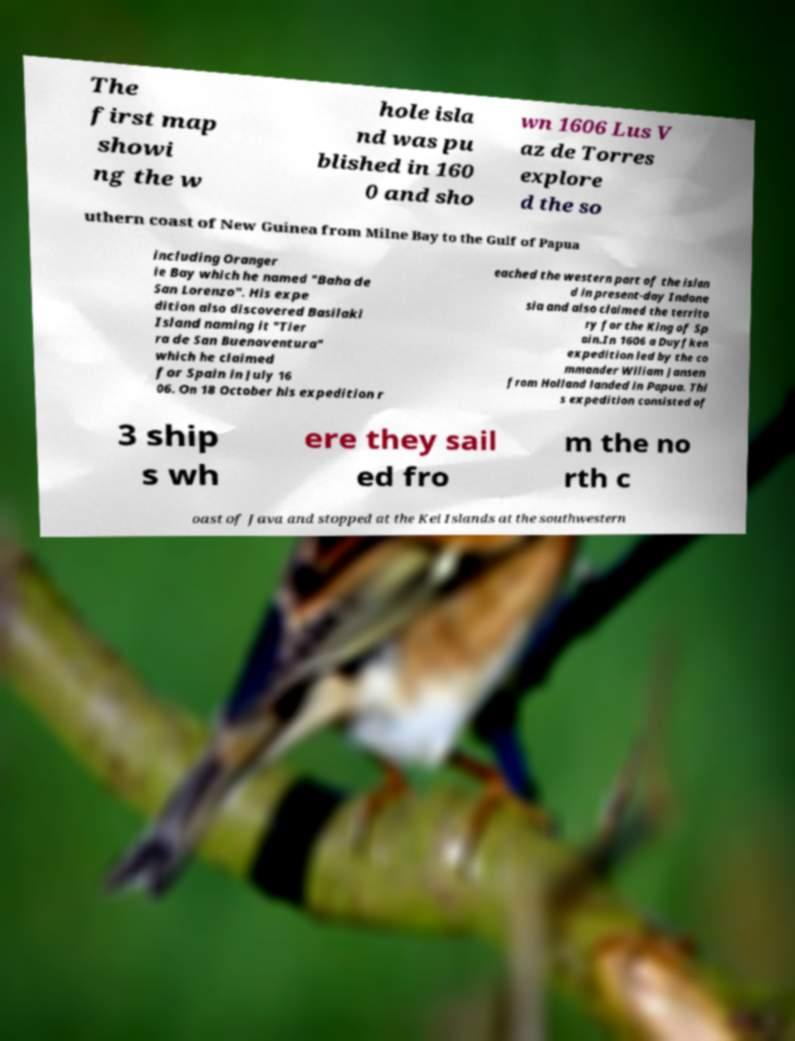Can you accurately transcribe the text from the provided image for me? The first map showi ng the w hole isla nd was pu blished in 160 0 and sho wn 1606 Lus V az de Torres explore d the so uthern coast of New Guinea from Milne Bay to the Gulf of Papua including Oranger ie Bay which he named "Baha de San Lorenzo". His expe dition also discovered Basilaki Island naming it "Tier ra de San Buenaventura" which he claimed for Spain in July 16 06. On 18 October his expedition r eached the western part of the islan d in present-day Indone sia and also claimed the territo ry for the King of Sp ain.In 1606 a Duyfken expedition led by the co mmander Wiliam Jansen from Holland landed in Papua. Thi s expedition consisted of 3 ship s wh ere they sail ed fro m the no rth c oast of Java and stopped at the Kei Islands at the southwestern 